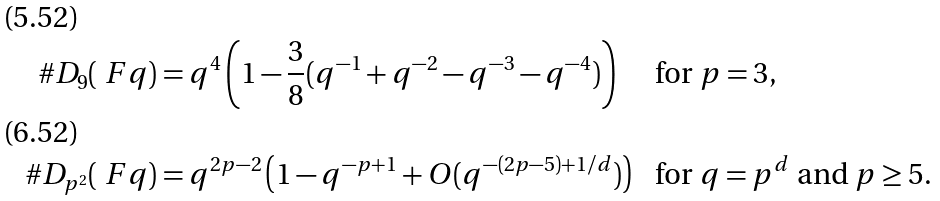Convert formula to latex. <formula><loc_0><loc_0><loc_500><loc_500>\# D _ { 9 } ( \ F q ) & = q ^ { 4 } \left ( 1 - \frac { 3 } { 8 } ( q ^ { - 1 } + q ^ { - 2 } - q ^ { - 3 } - q ^ { - 4 } ) \right ) & & \text {for $p = 3$} , \\ \# D _ { p ^ { 2 } } ( \ F q ) & = q ^ { 2 p - 2 } \left ( 1 - q ^ { - p + 1 } + O ( q ^ { - ( 2 p - 5 ) + 1 / d } ) \right ) & & \text {for $q = p^{d}$ and $p \geq 5$} .</formula> 